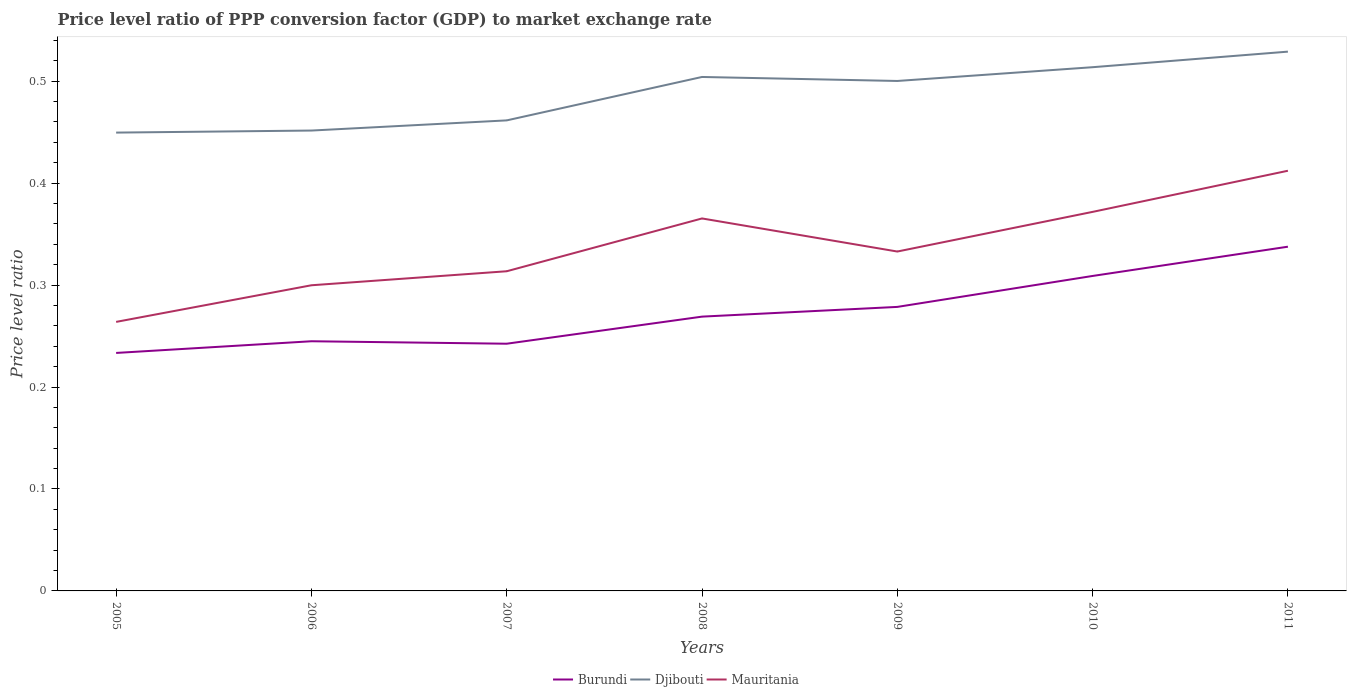Does the line corresponding to Djibouti intersect with the line corresponding to Mauritania?
Your answer should be very brief. No. Across all years, what is the maximum price level ratio in Burundi?
Offer a terse response. 0.23. In which year was the price level ratio in Djibouti maximum?
Provide a short and direct response. 2005. What is the total price level ratio in Burundi in the graph?
Give a very brief answer. -0.05. What is the difference between the highest and the second highest price level ratio in Mauritania?
Your answer should be very brief. 0.15. How many lines are there?
Your answer should be very brief. 3. How many years are there in the graph?
Your answer should be very brief. 7. Does the graph contain any zero values?
Your answer should be compact. No. Does the graph contain grids?
Keep it short and to the point. No. How many legend labels are there?
Give a very brief answer. 3. What is the title of the graph?
Ensure brevity in your answer.  Price level ratio of PPP conversion factor (GDP) to market exchange rate. Does "Slovenia" appear as one of the legend labels in the graph?
Keep it short and to the point. No. What is the label or title of the X-axis?
Keep it short and to the point. Years. What is the label or title of the Y-axis?
Make the answer very short. Price level ratio. What is the Price level ratio of Burundi in 2005?
Ensure brevity in your answer.  0.23. What is the Price level ratio of Djibouti in 2005?
Ensure brevity in your answer.  0.45. What is the Price level ratio of Mauritania in 2005?
Your answer should be compact. 0.26. What is the Price level ratio of Burundi in 2006?
Provide a short and direct response. 0.24. What is the Price level ratio of Djibouti in 2006?
Your answer should be compact. 0.45. What is the Price level ratio in Mauritania in 2006?
Your answer should be very brief. 0.3. What is the Price level ratio of Burundi in 2007?
Ensure brevity in your answer.  0.24. What is the Price level ratio of Djibouti in 2007?
Your answer should be very brief. 0.46. What is the Price level ratio of Mauritania in 2007?
Give a very brief answer. 0.31. What is the Price level ratio in Burundi in 2008?
Provide a short and direct response. 0.27. What is the Price level ratio of Djibouti in 2008?
Provide a succinct answer. 0.5. What is the Price level ratio in Mauritania in 2008?
Your answer should be very brief. 0.37. What is the Price level ratio in Burundi in 2009?
Your answer should be compact. 0.28. What is the Price level ratio of Djibouti in 2009?
Give a very brief answer. 0.5. What is the Price level ratio in Mauritania in 2009?
Offer a terse response. 0.33. What is the Price level ratio in Burundi in 2010?
Keep it short and to the point. 0.31. What is the Price level ratio of Djibouti in 2010?
Your answer should be very brief. 0.51. What is the Price level ratio in Mauritania in 2010?
Keep it short and to the point. 0.37. What is the Price level ratio in Burundi in 2011?
Keep it short and to the point. 0.34. What is the Price level ratio of Djibouti in 2011?
Provide a short and direct response. 0.53. What is the Price level ratio in Mauritania in 2011?
Provide a succinct answer. 0.41. Across all years, what is the maximum Price level ratio in Burundi?
Provide a succinct answer. 0.34. Across all years, what is the maximum Price level ratio of Djibouti?
Your answer should be very brief. 0.53. Across all years, what is the maximum Price level ratio in Mauritania?
Give a very brief answer. 0.41. Across all years, what is the minimum Price level ratio of Burundi?
Give a very brief answer. 0.23. Across all years, what is the minimum Price level ratio in Djibouti?
Ensure brevity in your answer.  0.45. Across all years, what is the minimum Price level ratio of Mauritania?
Your response must be concise. 0.26. What is the total Price level ratio of Burundi in the graph?
Your response must be concise. 1.91. What is the total Price level ratio in Djibouti in the graph?
Ensure brevity in your answer.  3.41. What is the total Price level ratio in Mauritania in the graph?
Your response must be concise. 2.36. What is the difference between the Price level ratio of Burundi in 2005 and that in 2006?
Your answer should be compact. -0.01. What is the difference between the Price level ratio of Djibouti in 2005 and that in 2006?
Your answer should be very brief. -0. What is the difference between the Price level ratio in Mauritania in 2005 and that in 2006?
Provide a succinct answer. -0.04. What is the difference between the Price level ratio of Burundi in 2005 and that in 2007?
Make the answer very short. -0.01. What is the difference between the Price level ratio of Djibouti in 2005 and that in 2007?
Offer a very short reply. -0.01. What is the difference between the Price level ratio in Mauritania in 2005 and that in 2007?
Your answer should be very brief. -0.05. What is the difference between the Price level ratio in Burundi in 2005 and that in 2008?
Offer a very short reply. -0.04. What is the difference between the Price level ratio of Djibouti in 2005 and that in 2008?
Give a very brief answer. -0.05. What is the difference between the Price level ratio in Mauritania in 2005 and that in 2008?
Make the answer very short. -0.1. What is the difference between the Price level ratio in Burundi in 2005 and that in 2009?
Make the answer very short. -0.05. What is the difference between the Price level ratio of Djibouti in 2005 and that in 2009?
Your answer should be very brief. -0.05. What is the difference between the Price level ratio in Mauritania in 2005 and that in 2009?
Provide a short and direct response. -0.07. What is the difference between the Price level ratio in Burundi in 2005 and that in 2010?
Provide a short and direct response. -0.08. What is the difference between the Price level ratio of Djibouti in 2005 and that in 2010?
Keep it short and to the point. -0.06. What is the difference between the Price level ratio of Mauritania in 2005 and that in 2010?
Make the answer very short. -0.11. What is the difference between the Price level ratio in Burundi in 2005 and that in 2011?
Keep it short and to the point. -0.1. What is the difference between the Price level ratio of Djibouti in 2005 and that in 2011?
Offer a terse response. -0.08. What is the difference between the Price level ratio in Mauritania in 2005 and that in 2011?
Offer a very short reply. -0.15. What is the difference between the Price level ratio in Burundi in 2006 and that in 2007?
Your response must be concise. 0. What is the difference between the Price level ratio in Djibouti in 2006 and that in 2007?
Make the answer very short. -0.01. What is the difference between the Price level ratio of Mauritania in 2006 and that in 2007?
Provide a succinct answer. -0.01. What is the difference between the Price level ratio in Burundi in 2006 and that in 2008?
Make the answer very short. -0.02. What is the difference between the Price level ratio in Djibouti in 2006 and that in 2008?
Your answer should be compact. -0.05. What is the difference between the Price level ratio in Mauritania in 2006 and that in 2008?
Provide a succinct answer. -0.07. What is the difference between the Price level ratio of Burundi in 2006 and that in 2009?
Keep it short and to the point. -0.03. What is the difference between the Price level ratio of Djibouti in 2006 and that in 2009?
Your answer should be very brief. -0.05. What is the difference between the Price level ratio in Mauritania in 2006 and that in 2009?
Provide a succinct answer. -0.03. What is the difference between the Price level ratio in Burundi in 2006 and that in 2010?
Give a very brief answer. -0.06. What is the difference between the Price level ratio of Djibouti in 2006 and that in 2010?
Offer a terse response. -0.06. What is the difference between the Price level ratio in Mauritania in 2006 and that in 2010?
Provide a succinct answer. -0.07. What is the difference between the Price level ratio of Burundi in 2006 and that in 2011?
Your answer should be compact. -0.09. What is the difference between the Price level ratio of Djibouti in 2006 and that in 2011?
Your answer should be compact. -0.08. What is the difference between the Price level ratio in Mauritania in 2006 and that in 2011?
Your response must be concise. -0.11. What is the difference between the Price level ratio in Burundi in 2007 and that in 2008?
Offer a terse response. -0.03. What is the difference between the Price level ratio of Djibouti in 2007 and that in 2008?
Give a very brief answer. -0.04. What is the difference between the Price level ratio of Mauritania in 2007 and that in 2008?
Your response must be concise. -0.05. What is the difference between the Price level ratio of Burundi in 2007 and that in 2009?
Keep it short and to the point. -0.04. What is the difference between the Price level ratio of Djibouti in 2007 and that in 2009?
Your answer should be compact. -0.04. What is the difference between the Price level ratio of Mauritania in 2007 and that in 2009?
Give a very brief answer. -0.02. What is the difference between the Price level ratio in Burundi in 2007 and that in 2010?
Provide a short and direct response. -0.07. What is the difference between the Price level ratio in Djibouti in 2007 and that in 2010?
Provide a short and direct response. -0.05. What is the difference between the Price level ratio of Mauritania in 2007 and that in 2010?
Make the answer very short. -0.06. What is the difference between the Price level ratio of Burundi in 2007 and that in 2011?
Your answer should be compact. -0.1. What is the difference between the Price level ratio of Djibouti in 2007 and that in 2011?
Provide a short and direct response. -0.07. What is the difference between the Price level ratio of Mauritania in 2007 and that in 2011?
Keep it short and to the point. -0.1. What is the difference between the Price level ratio of Burundi in 2008 and that in 2009?
Offer a terse response. -0.01. What is the difference between the Price level ratio of Djibouti in 2008 and that in 2009?
Offer a very short reply. 0. What is the difference between the Price level ratio in Mauritania in 2008 and that in 2009?
Offer a very short reply. 0.03. What is the difference between the Price level ratio of Burundi in 2008 and that in 2010?
Offer a terse response. -0.04. What is the difference between the Price level ratio in Djibouti in 2008 and that in 2010?
Offer a terse response. -0.01. What is the difference between the Price level ratio of Mauritania in 2008 and that in 2010?
Provide a succinct answer. -0.01. What is the difference between the Price level ratio in Burundi in 2008 and that in 2011?
Your answer should be very brief. -0.07. What is the difference between the Price level ratio of Djibouti in 2008 and that in 2011?
Provide a short and direct response. -0.02. What is the difference between the Price level ratio in Mauritania in 2008 and that in 2011?
Give a very brief answer. -0.05. What is the difference between the Price level ratio of Burundi in 2009 and that in 2010?
Provide a succinct answer. -0.03. What is the difference between the Price level ratio in Djibouti in 2009 and that in 2010?
Your answer should be compact. -0.01. What is the difference between the Price level ratio in Mauritania in 2009 and that in 2010?
Offer a very short reply. -0.04. What is the difference between the Price level ratio of Burundi in 2009 and that in 2011?
Give a very brief answer. -0.06. What is the difference between the Price level ratio in Djibouti in 2009 and that in 2011?
Offer a very short reply. -0.03. What is the difference between the Price level ratio of Mauritania in 2009 and that in 2011?
Keep it short and to the point. -0.08. What is the difference between the Price level ratio of Burundi in 2010 and that in 2011?
Provide a short and direct response. -0.03. What is the difference between the Price level ratio of Djibouti in 2010 and that in 2011?
Your answer should be compact. -0.02. What is the difference between the Price level ratio of Mauritania in 2010 and that in 2011?
Ensure brevity in your answer.  -0.04. What is the difference between the Price level ratio in Burundi in 2005 and the Price level ratio in Djibouti in 2006?
Your response must be concise. -0.22. What is the difference between the Price level ratio of Burundi in 2005 and the Price level ratio of Mauritania in 2006?
Your response must be concise. -0.07. What is the difference between the Price level ratio in Djibouti in 2005 and the Price level ratio in Mauritania in 2006?
Offer a very short reply. 0.15. What is the difference between the Price level ratio of Burundi in 2005 and the Price level ratio of Djibouti in 2007?
Your response must be concise. -0.23. What is the difference between the Price level ratio of Burundi in 2005 and the Price level ratio of Mauritania in 2007?
Ensure brevity in your answer.  -0.08. What is the difference between the Price level ratio in Djibouti in 2005 and the Price level ratio in Mauritania in 2007?
Your answer should be compact. 0.14. What is the difference between the Price level ratio in Burundi in 2005 and the Price level ratio in Djibouti in 2008?
Give a very brief answer. -0.27. What is the difference between the Price level ratio in Burundi in 2005 and the Price level ratio in Mauritania in 2008?
Make the answer very short. -0.13. What is the difference between the Price level ratio of Djibouti in 2005 and the Price level ratio of Mauritania in 2008?
Keep it short and to the point. 0.08. What is the difference between the Price level ratio in Burundi in 2005 and the Price level ratio in Djibouti in 2009?
Your response must be concise. -0.27. What is the difference between the Price level ratio in Burundi in 2005 and the Price level ratio in Mauritania in 2009?
Give a very brief answer. -0.1. What is the difference between the Price level ratio of Djibouti in 2005 and the Price level ratio of Mauritania in 2009?
Provide a short and direct response. 0.12. What is the difference between the Price level ratio in Burundi in 2005 and the Price level ratio in Djibouti in 2010?
Provide a short and direct response. -0.28. What is the difference between the Price level ratio of Burundi in 2005 and the Price level ratio of Mauritania in 2010?
Your answer should be compact. -0.14. What is the difference between the Price level ratio of Djibouti in 2005 and the Price level ratio of Mauritania in 2010?
Provide a succinct answer. 0.08. What is the difference between the Price level ratio of Burundi in 2005 and the Price level ratio of Djibouti in 2011?
Offer a terse response. -0.3. What is the difference between the Price level ratio of Burundi in 2005 and the Price level ratio of Mauritania in 2011?
Offer a terse response. -0.18. What is the difference between the Price level ratio in Djibouti in 2005 and the Price level ratio in Mauritania in 2011?
Your answer should be compact. 0.04. What is the difference between the Price level ratio of Burundi in 2006 and the Price level ratio of Djibouti in 2007?
Your answer should be compact. -0.22. What is the difference between the Price level ratio of Burundi in 2006 and the Price level ratio of Mauritania in 2007?
Give a very brief answer. -0.07. What is the difference between the Price level ratio of Djibouti in 2006 and the Price level ratio of Mauritania in 2007?
Give a very brief answer. 0.14. What is the difference between the Price level ratio in Burundi in 2006 and the Price level ratio in Djibouti in 2008?
Your response must be concise. -0.26. What is the difference between the Price level ratio in Burundi in 2006 and the Price level ratio in Mauritania in 2008?
Give a very brief answer. -0.12. What is the difference between the Price level ratio in Djibouti in 2006 and the Price level ratio in Mauritania in 2008?
Make the answer very short. 0.09. What is the difference between the Price level ratio of Burundi in 2006 and the Price level ratio of Djibouti in 2009?
Your answer should be compact. -0.26. What is the difference between the Price level ratio of Burundi in 2006 and the Price level ratio of Mauritania in 2009?
Offer a very short reply. -0.09. What is the difference between the Price level ratio in Djibouti in 2006 and the Price level ratio in Mauritania in 2009?
Your response must be concise. 0.12. What is the difference between the Price level ratio of Burundi in 2006 and the Price level ratio of Djibouti in 2010?
Make the answer very short. -0.27. What is the difference between the Price level ratio in Burundi in 2006 and the Price level ratio in Mauritania in 2010?
Ensure brevity in your answer.  -0.13. What is the difference between the Price level ratio in Djibouti in 2006 and the Price level ratio in Mauritania in 2010?
Your answer should be compact. 0.08. What is the difference between the Price level ratio in Burundi in 2006 and the Price level ratio in Djibouti in 2011?
Your answer should be very brief. -0.28. What is the difference between the Price level ratio in Burundi in 2006 and the Price level ratio in Mauritania in 2011?
Provide a short and direct response. -0.17. What is the difference between the Price level ratio of Djibouti in 2006 and the Price level ratio of Mauritania in 2011?
Give a very brief answer. 0.04. What is the difference between the Price level ratio in Burundi in 2007 and the Price level ratio in Djibouti in 2008?
Provide a short and direct response. -0.26. What is the difference between the Price level ratio in Burundi in 2007 and the Price level ratio in Mauritania in 2008?
Offer a very short reply. -0.12. What is the difference between the Price level ratio of Djibouti in 2007 and the Price level ratio of Mauritania in 2008?
Offer a terse response. 0.1. What is the difference between the Price level ratio of Burundi in 2007 and the Price level ratio of Djibouti in 2009?
Offer a terse response. -0.26. What is the difference between the Price level ratio of Burundi in 2007 and the Price level ratio of Mauritania in 2009?
Make the answer very short. -0.09. What is the difference between the Price level ratio in Djibouti in 2007 and the Price level ratio in Mauritania in 2009?
Offer a terse response. 0.13. What is the difference between the Price level ratio in Burundi in 2007 and the Price level ratio in Djibouti in 2010?
Give a very brief answer. -0.27. What is the difference between the Price level ratio in Burundi in 2007 and the Price level ratio in Mauritania in 2010?
Keep it short and to the point. -0.13. What is the difference between the Price level ratio of Djibouti in 2007 and the Price level ratio of Mauritania in 2010?
Keep it short and to the point. 0.09. What is the difference between the Price level ratio in Burundi in 2007 and the Price level ratio in Djibouti in 2011?
Offer a terse response. -0.29. What is the difference between the Price level ratio in Burundi in 2007 and the Price level ratio in Mauritania in 2011?
Offer a terse response. -0.17. What is the difference between the Price level ratio of Djibouti in 2007 and the Price level ratio of Mauritania in 2011?
Provide a succinct answer. 0.05. What is the difference between the Price level ratio in Burundi in 2008 and the Price level ratio in Djibouti in 2009?
Make the answer very short. -0.23. What is the difference between the Price level ratio of Burundi in 2008 and the Price level ratio of Mauritania in 2009?
Ensure brevity in your answer.  -0.06. What is the difference between the Price level ratio in Djibouti in 2008 and the Price level ratio in Mauritania in 2009?
Ensure brevity in your answer.  0.17. What is the difference between the Price level ratio of Burundi in 2008 and the Price level ratio of Djibouti in 2010?
Make the answer very short. -0.24. What is the difference between the Price level ratio of Burundi in 2008 and the Price level ratio of Mauritania in 2010?
Offer a very short reply. -0.1. What is the difference between the Price level ratio of Djibouti in 2008 and the Price level ratio of Mauritania in 2010?
Your response must be concise. 0.13. What is the difference between the Price level ratio in Burundi in 2008 and the Price level ratio in Djibouti in 2011?
Your response must be concise. -0.26. What is the difference between the Price level ratio in Burundi in 2008 and the Price level ratio in Mauritania in 2011?
Make the answer very short. -0.14. What is the difference between the Price level ratio in Djibouti in 2008 and the Price level ratio in Mauritania in 2011?
Keep it short and to the point. 0.09. What is the difference between the Price level ratio in Burundi in 2009 and the Price level ratio in Djibouti in 2010?
Provide a short and direct response. -0.24. What is the difference between the Price level ratio in Burundi in 2009 and the Price level ratio in Mauritania in 2010?
Offer a terse response. -0.09. What is the difference between the Price level ratio in Djibouti in 2009 and the Price level ratio in Mauritania in 2010?
Offer a very short reply. 0.13. What is the difference between the Price level ratio of Burundi in 2009 and the Price level ratio of Djibouti in 2011?
Give a very brief answer. -0.25. What is the difference between the Price level ratio in Burundi in 2009 and the Price level ratio in Mauritania in 2011?
Provide a succinct answer. -0.13. What is the difference between the Price level ratio in Djibouti in 2009 and the Price level ratio in Mauritania in 2011?
Your response must be concise. 0.09. What is the difference between the Price level ratio of Burundi in 2010 and the Price level ratio of Djibouti in 2011?
Ensure brevity in your answer.  -0.22. What is the difference between the Price level ratio of Burundi in 2010 and the Price level ratio of Mauritania in 2011?
Provide a short and direct response. -0.1. What is the difference between the Price level ratio of Djibouti in 2010 and the Price level ratio of Mauritania in 2011?
Ensure brevity in your answer.  0.1. What is the average Price level ratio of Burundi per year?
Offer a terse response. 0.27. What is the average Price level ratio in Djibouti per year?
Provide a short and direct response. 0.49. What is the average Price level ratio in Mauritania per year?
Keep it short and to the point. 0.34. In the year 2005, what is the difference between the Price level ratio of Burundi and Price level ratio of Djibouti?
Give a very brief answer. -0.22. In the year 2005, what is the difference between the Price level ratio of Burundi and Price level ratio of Mauritania?
Your answer should be compact. -0.03. In the year 2005, what is the difference between the Price level ratio of Djibouti and Price level ratio of Mauritania?
Give a very brief answer. 0.19. In the year 2006, what is the difference between the Price level ratio in Burundi and Price level ratio in Djibouti?
Offer a terse response. -0.21. In the year 2006, what is the difference between the Price level ratio of Burundi and Price level ratio of Mauritania?
Provide a short and direct response. -0.05. In the year 2006, what is the difference between the Price level ratio of Djibouti and Price level ratio of Mauritania?
Make the answer very short. 0.15. In the year 2007, what is the difference between the Price level ratio of Burundi and Price level ratio of Djibouti?
Your answer should be very brief. -0.22. In the year 2007, what is the difference between the Price level ratio in Burundi and Price level ratio in Mauritania?
Your answer should be compact. -0.07. In the year 2007, what is the difference between the Price level ratio in Djibouti and Price level ratio in Mauritania?
Your answer should be compact. 0.15. In the year 2008, what is the difference between the Price level ratio in Burundi and Price level ratio in Djibouti?
Provide a succinct answer. -0.24. In the year 2008, what is the difference between the Price level ratio of Burundi and Price level ratio of Mauritania?
Your response must be concise. -0.1. In the year 2008, what is the difference between the Price level ratio in Djibouti and Price level ratio in Mauritania?
Offer a terse response. 0.14. In the year 2009, what is the difference between the Price level ratio of Burundi and Price level ratio of Djibouti?
Give a very brief answer. -0.22. In the year 2009, what is the difference between the Price level ratio in Burundi and Price level ratio in Mauritania?
Provide a short and direct response. -0.05. In the year 2009, what is the difference between the Price level ratio in Djibouti and Price level ratio in Mauritania?
Make the answer very short. 0.17. In the year 2010, what is the difference between the Price level ratio of Burundi and Price level ratio of Djibouti?
Provide a short and direct response. -0.2. In the year 2010, what is the difference between the Price level ratio in Burundi and Price level ratio in Mauritania?
Your response must be concise. -0.06. In the year 2010, what is the difference between the Price level ratio in Djibouti and Price level ratio in Mauritania?
Your answer should be compact. 0.14. In the year 2011, what is the difference between the Price level ratio in Burundi and Price level ratio in Djibouti?
Your answer should be compact. -0.19. In the year 2011, what is the difference between the Price level ratio of Burundi and Price level ratio of Mauritania?
Offer a terse response. -0.07. In the year 2011, what is the difference between the Price level ratio of Djibouti and Price level ratio of Mauritania?
Provide a succinct answer. 0.12. What is the ratio of the Price level ratio in Burundi in 2005 to that in 2006?
Keep it short and to the point. 0.95. What is the ratio of the Price level ratio in Djibouti in 2005 to that in 2006?
Provide a short and direct response. 1. What is the ratio of the Price level ratio of Mauritania in 2005 to that in 2006?
Your answer should be very brief. 0.88. What is the ratio of the Price level ratio in Burundi in 2005 to that in 2007?
Ensure brevity in your answer.  0.96. What is the ratio of the Price level ratio in Mauritania in 2005 to that in 2007?
Keep it short and to the point. 0.84. What is the ratio of the Price level ratio of Burundi in 2005 to that in 2008?
Provide a succinct answer. 0.87. What is the ratio of the Price level ratio of Djibouti in 2005 to that in 2008?
Ensure brevity in your answer.  0.89. What is the ratio of the Price level ratio of Mauritania in 2005 to that in 2008?
Make the answer very short. 0.72. What is the ratio of the Price level ratio of Burundi in 2005 to that in 2009?
Your answer should be very brief. 0.84. What is the ratio of the Price level ratio in Djibouti in 2005 to that in 2009?
Your answer should be very brief. 0.9. What is the ratio of the Price level ratio of Mauritania in 2005 to that in 2009?
Your response must be concise. 0.79. What is the ratio of the Price level ratio of Burundi in 2005 to that in 2010?
Provide a succinct answer. 0.76. What is the ratio of the Price level ratio of Djibouti in 2005 to that in 2010?
Your answer should be compact. 0.88. What is the ratio of the Price level ratio of Mauritania in 2005 to that in 2010?
Your answer should be very brief. 0.71. What is the ratio of the Price level ratio of Burundi in 2005 to that in 2011?
Give a very brief answer. 0.69. What is the ratio of the Price level ratio in Djibouti in 2005 to that in 2011?
Give a very brief answer. 0.85. What is the ratio of the Price level ratio of Mauritania in 2005 to that in 2011?
Make the answer very short. 0.64. What is the ratio of the Price level ratio in Burundi in 2006 to that in 2007?
Offer a very short reply. 1.01. What is the ratio of the Price level ratio in Djibouti in 2006 to that in 2007?
Your response must be concise. 0.98. What is the ratio of the Price level ratio in Mauritania in 2006 to that in 2007?
Offer a terse response. 0.96. What is the ratio of the Price level ratio of Burundi in 2006 to that in 2008?
Your answer should be very brief. 0.91. What is the ratio of the Price level ratio in Djibouti in 2006 to that in 2008?
Give a very brief answer. 0.9. What is the ratio of the Price level ratio in Mauritania in 2006 to that in 2008?
Offer a very short reply. 0.82. What is the ratio of the Price level ratio in Burundi in 2006 to that in 2009?
Provide a succinct answer. 0.88. What is the ratio of the Price level ratio of Djibouti in 2006 to that in 2009?
Provide a short and direct response. 0.9. What is the ratio of the Price level ratio of Mauritania in 2006 to that in 2009?
Ensure brevity in your answer.  0.9. What is the ratio of the Price level ratio in Burundi in 2006 to that in 2010?
Keep it short and to the point. 0.79. What is the ratio of the Price level ratio in Djibouti in 2006 to that in 2010?
Provide a short and direct response. 0.88. What is the ratio of the Price level ratio of Mauritania in 2006 to that in 2010?
Keep it short and to the point. 0.81. What is the ratio of the Price level ratio of Burundi in 2006 to that in 2011?
Your answer should be compact. 0.73. What is the ratio of the Price level ratio in Djibouti in 2006 to that in 2011?
Make the answer very short. 0.85. What is the ratio of the Price level ratio in Mauritania in 2006 to that in 2011?
Give a very brief answer. 0.73. What is the ratio of the Price level ratio of Burundi in 2007 to that in 2008?
Give a very brief answer. 0.9. What is the ratio of the Price level ratio of Djibouti in 2007 to that in 2008?
Offer a terse response. 0.92. What is the ratio of the Price level ratio in Mauritania in 2007 to that in 2008?
Your answer should be compact. 0.86. What is the ratio of the Price level ratio of Burundi in 2007 to that in 2009?
Your answer should be compact. 0.87. What is the ratio of the Price level ratio in Djibouti in 2007 to that in 2009?
Offer a terse response. 0.92. What is the ratio of the Price level ratio in Mauritania in 2007 to that in 2009?
Make the answer very short. 0.94. What is the ratio of the Price level ratio of Burundi in 2007 to that in 2010?
Ensure brevity in your answer.  0.78. What is the ratio of the Price level ratio of Djibouti in 2007 to that in 2010?
Provide a succinct answer. 0.9. What is the ratio of the Price level ratio of Mauritania in 2007 to that in 2010?
Keep it short and to the point. 0.84. What is the ratio of the Price level ratio of Burundi in 2007 to that in 2011?
Your response must be concise. 0.72. What is the ratio of the Price level ratio of Djibouti in 2007 to that in 2011?
Provide a short and direct response. 0.87. What is the ratio of the Price level ratio in Mauritania in 2007 to that in 2011?
Make the answer very short. 0.76. What is the ratio of the Price level ratio in Burundi in 2008 to that in 2009?
Give a very brief answer. 0.97. What is the ratio of the Price level ratio of Djibouti in 2008 to that in 2009?
Provide a succinct answer. 1.01. What is the ratio of the Price level ratio of Mauritania in 2008 to that in 2009?
Provide a short and direct response. 1.1. What is the ratio of the Price level ratio in Burundi in 2008 to that in 2010?
Make the answer very short. 0.87. What is the ratio of the Price level ratio in Djibouti in 2008 to that in 2010?
Give a very brief answer. 0.98. What is the ratio of the Price level ratio in Mauritania in 2008 to that in 2010?
Your answer should be compact. 0.98. What is the ratio of the Price level ratio in Burundi in 2008 to that in 2011?
Keep it short and to the point. 0.8. What is the ratio of the Price level ratio of Djibouti in 2008 to that in 2011?
Offer a terse response. 0.95. What is the ratio of the Price level ratio in Mauritania in 2008 to that in 2011?
Your answer should be compact. 0.89. What is the ratio of the Price level ratio in Burundi in 2009 to that in 2010?
Ensure brevity in your answer.  0.9. What is the ratio of the Price level ratio of Djibouti in 2009 to that in 2010?
Your answer should be very brief. 0.97. What is the ratio of the Price level ratio in Mauritania in 2009 to that in 2010?
Provide a short and direct response. 0.9. What is the ratio of the Price level ratio of Burundi in 2009 to that in 2011?
Keep it short and to the point. 0.83. What is the ratio of the Price level ratio in Djibouti in 2009 to that in 2011?
Your answer should be very brief. 0.95. What is the ratio of the Price level ratio in Mauritania in 2009 to that in 2011?
Your response must be concise. 0.81. What is the ratio of the Price level ratio in Burundi in 2010 to that in 2011?
Provide a short and direct response. 0.92. What is the ratio of the Price level ratio in Djibouti in 2010 to that in 2011?
Give a very brief answer. 0.97. What is the ratio of the Price level ratio of Mauritania in 2010 to that in 2011?
Your answer should be compact. 0.9. What is the difference between the highest and the second highest Price level ratio in Burundi?
Provide a succinct answer. 0.03. What is the difference between the highest and the second highest Price level ratio in Djibouti?
Keep it short and to the point. 0.02. What is the difference between the highest and the second highest Price level ratio in Mauritania?
Give a very brief answer. 0.04. What is the difference between the highest and the lowest Price level ratio of Burundi?
Provide a short and direct response. 0.1. What is the difference between the highest and the lowest Price level ratio in Djibouti?
Give a very brief answer. 0.08. What is the difference between the highest and the lowest Price level ratio of Mauritania?
Your response must be concise. 0.15. 